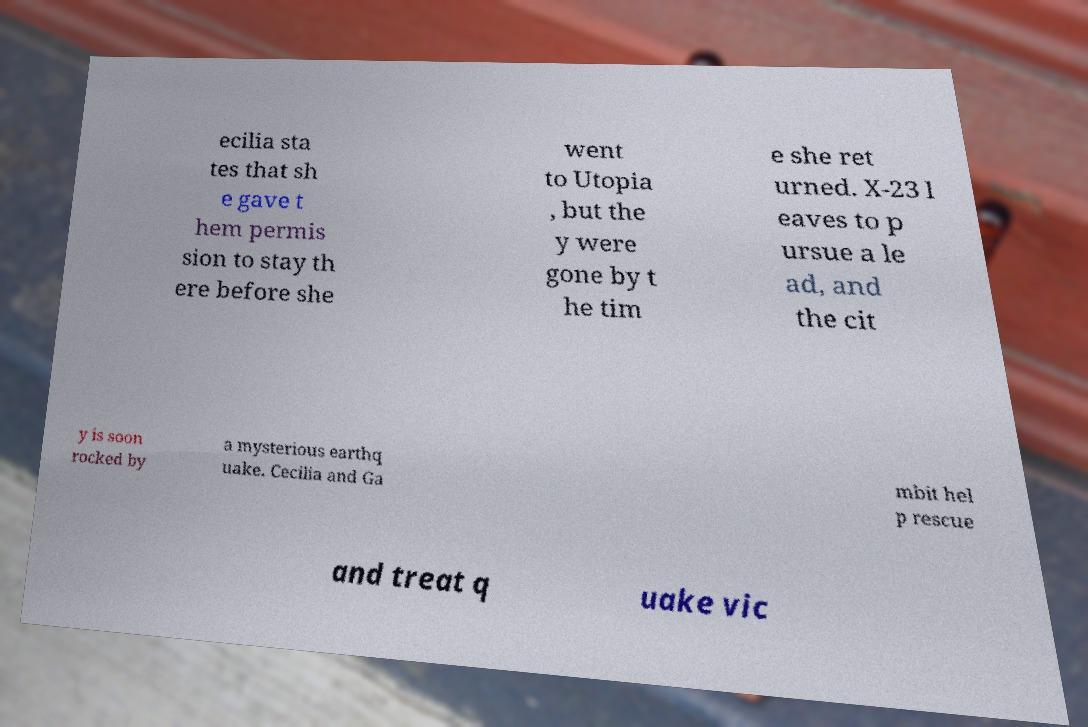What messages or text are displayed in this image? I need them in a readable, typed format. ecilia sta tes that sh e gave t hem permis sion to stay th ere before she went to Utopia , but the y were gone by t he tim e she ret urned. X-23 l eaves to p ursue a le ad, and the cit y is soon rocked by a mysterious earthq uake. Cecilia and Ga mbit hel p rescue and treat q uake vic 